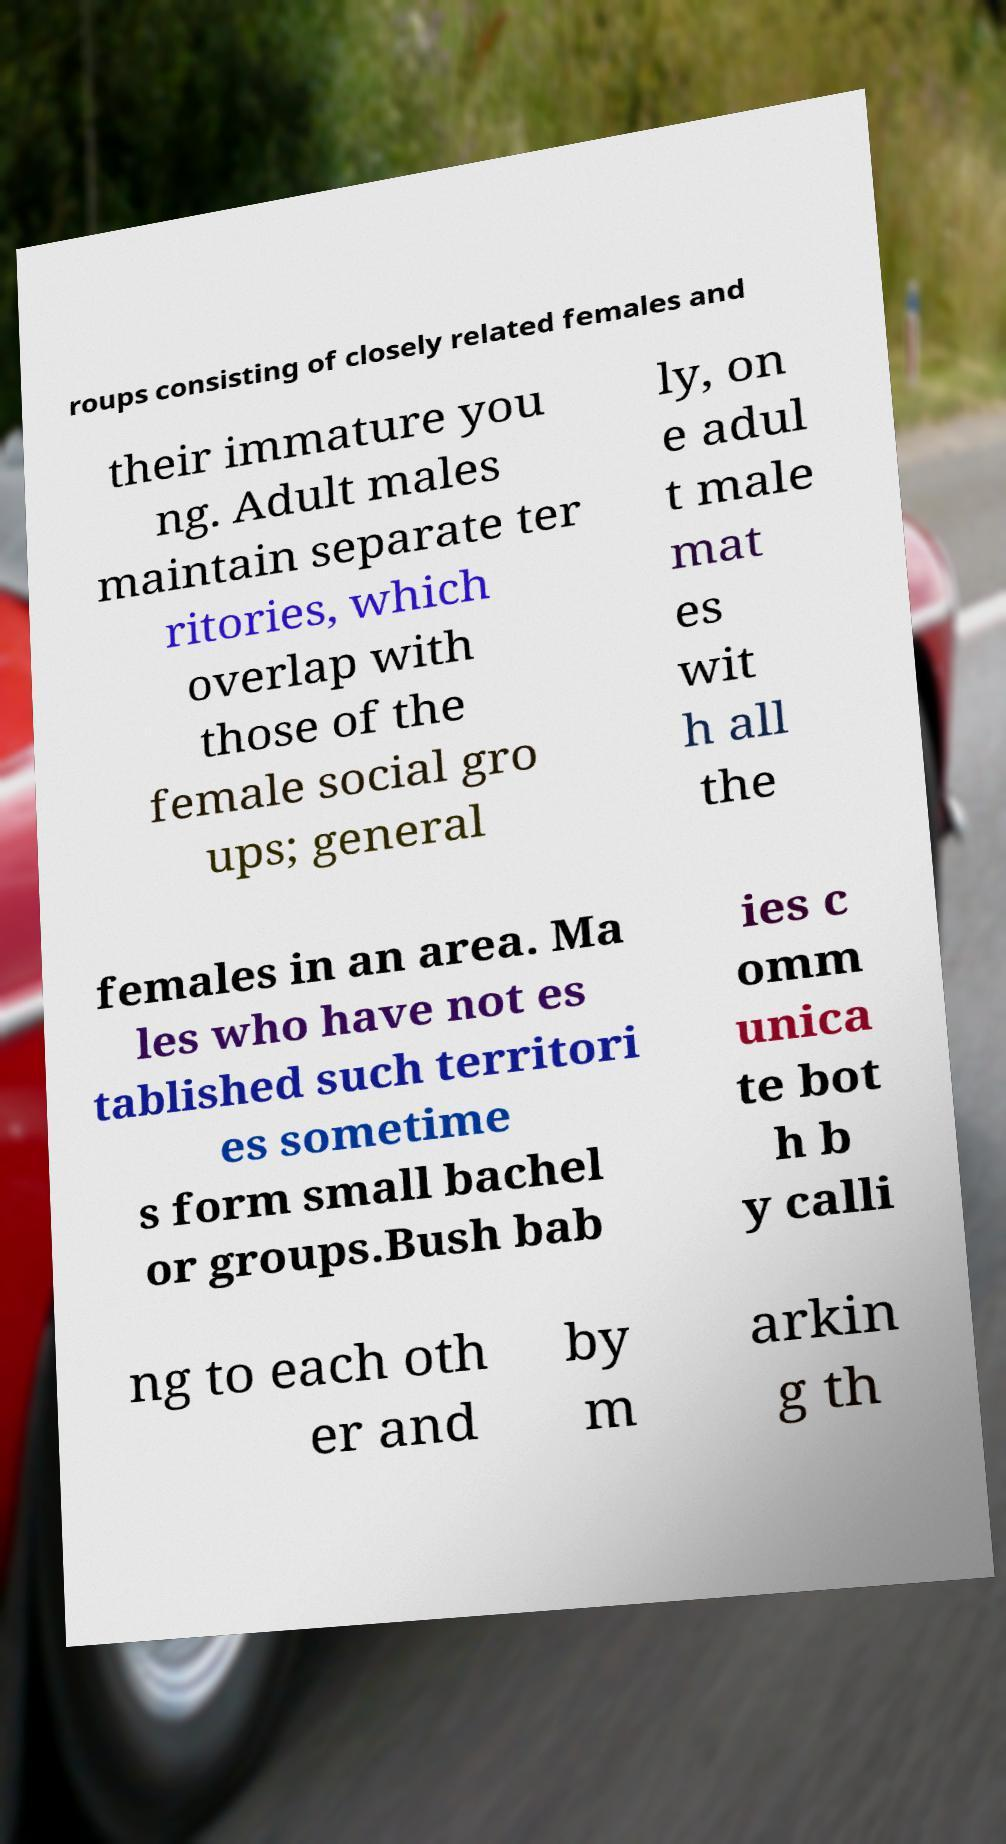Could you assist in decoding the text presented in this image and type it out clearly? roups consisting of closely related females and their immature you ng. Adult males maintain separate ter ritories, which overlap with those of the female social gro ups; general ly, on e adul t male mat es wit h all the females in an area. Ma les who have not es tablished such territori es sometime s form small bachel or groups.Bush bab ies c omm unica te bot h b y calli ng to each oth er and by m arkin g th 